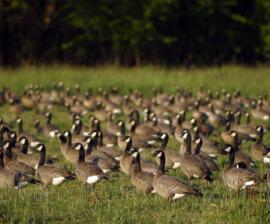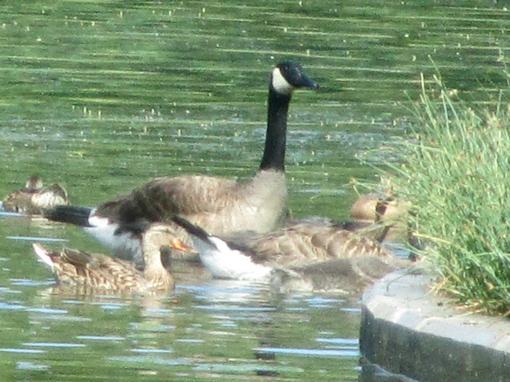The first image is the image on the left, the second image is the image on the right. For the images shown, is this caption "There are multiple birds walking and grazing on patchy grass with dirt showing." true? Answer yes or no. No. The first image is the image on the left, the second image is the image on the right. Considering the images on both sides, is "The only living creatures in the image on the left are either adult or juvenile Canadian geese, too many to count." valid? Answer yes or no. Yes. 